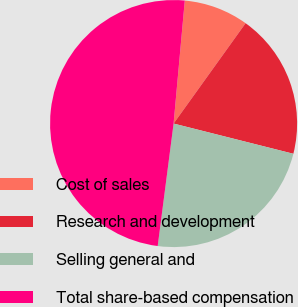Convert chart to OTSL. <chart><loc_0><loc_0><loc_500><loc_500><pie_chart><fcel>Cost of sales<fcel>Research and development<fcel>Selling general and<fcel>Total share-based compensation<nl><fcel>8.46%<fcel>19.03%<fcel>23.12%<fcel>49.39%<nl></chart> 